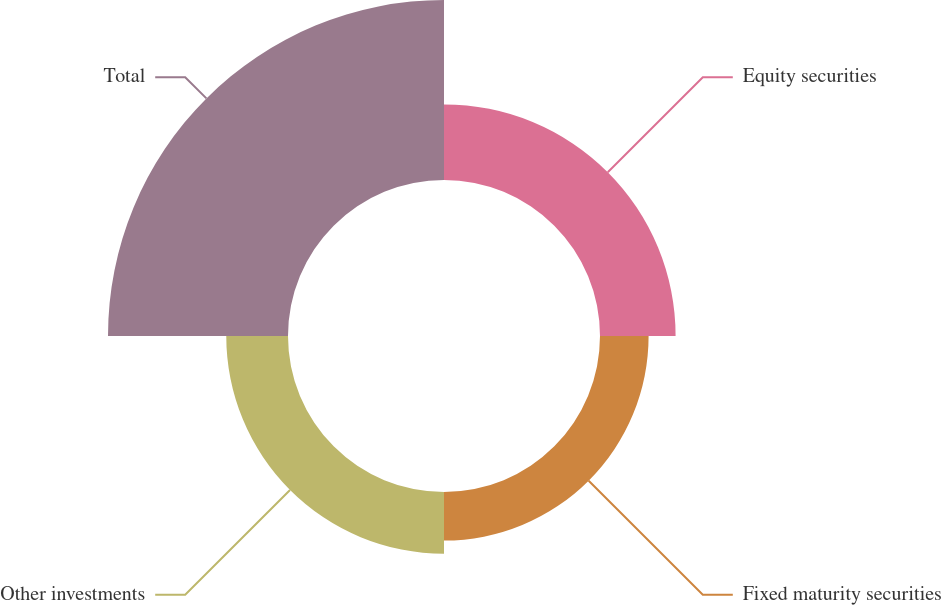Convert chart. <chart><loc_0><loc_0><loc_500><loc_500><pie_chart><fcel>Equity securities<fcel>Fixed maturity securities<fcel>Other investments<fcel>Total<nl><fcel>20.66%<fcel>13.28%<fcel>16.87%<fcel>49.19%<nl></chart> 